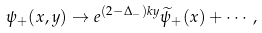Convert formula to latex. <formula><loc_0><loc_0><loc_500><loc_500>\psi _ { + } ( x , y ) \rightarrow e ^ { ( 2 - \Delta _ { - } ) k y } \widetilde { \psi } _ { + } ( x ) + \cdots ,</formula> 